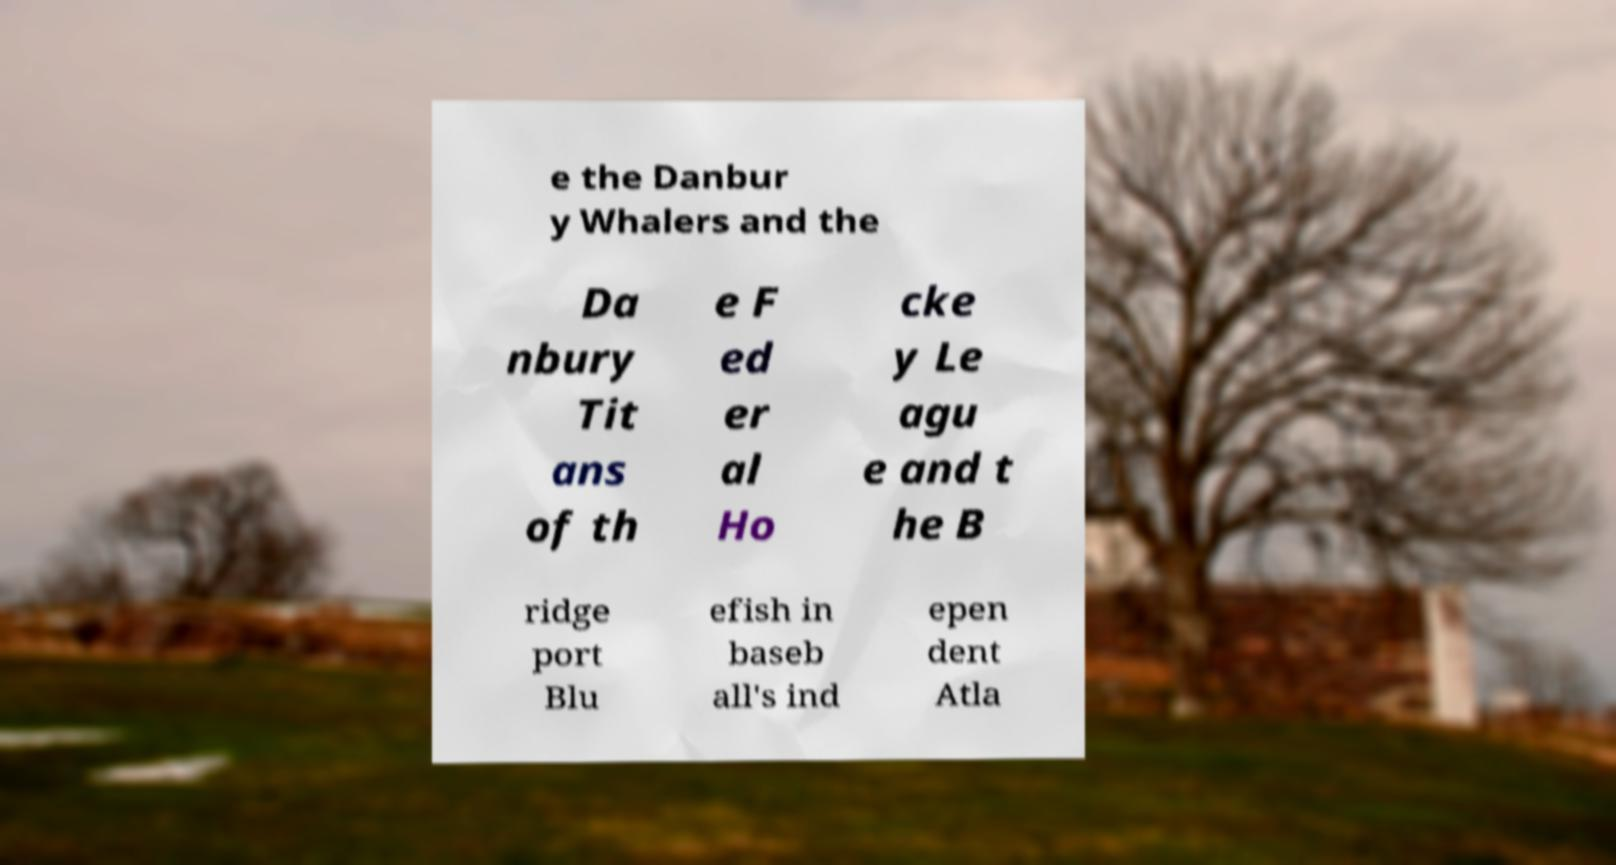For documentation purposes, I need the text within this image transcribed. Could you provide that? e the Danbur y Whalers and the Da nbury Tit ans of th e F ed er al Ho cke y Le agu e and t he B ridge port Blu efish in baseb all's ind epen dent Atla 